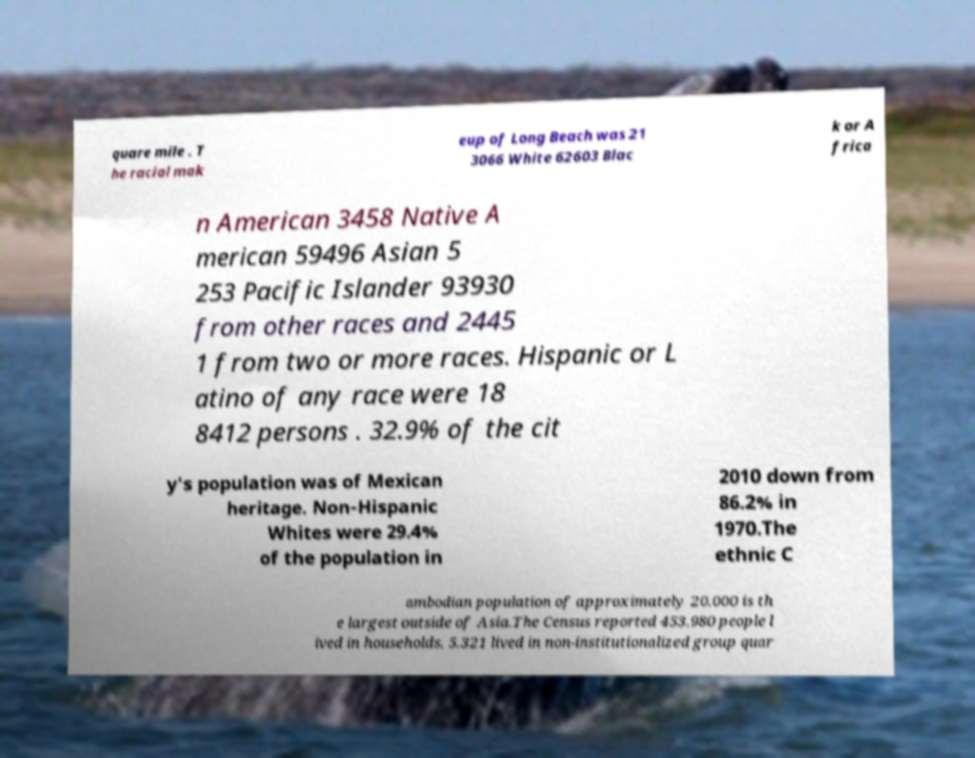Could you assist in decoding the text presented in this image and type it out clearly? quare mile . T he racial mak eup of Long Beach was 21 3066 White 62603 Blac k or A frica n American 3458 Native A merican 59496 Asian 5 253 Pacific Islander 93930 from other races and 2445 1 from two or more races. Hispanic or L atino of any race were 18 8412 persons . 32.9% of the cit y's population was of Mexican heritage. Non-Hispanic Whites were 29.4% of the population in 2010 down from 86.2% in 1970.The ethnic C ambodian population of approximately 20,000 is th e largest outside of Asia.The Census reported 453,980 people l ived in households, 5,321 lived in non-institutionalized group quar 